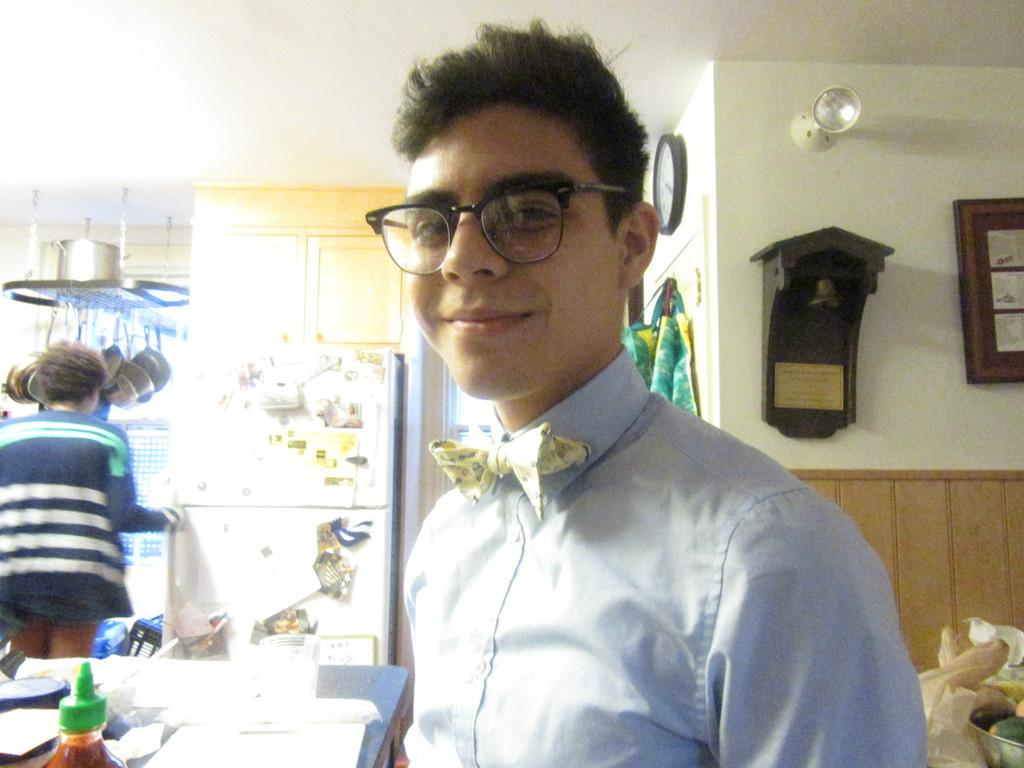What is the main subject of the image? There is a person in the image. What is the person doing in the image? The person is standing and laughing. What other object can be seen in the image? There is a table in the image. What type of rake is the person using to create friction in the image? There is no rake or friction present in the image; it features a person standing and laughing. 